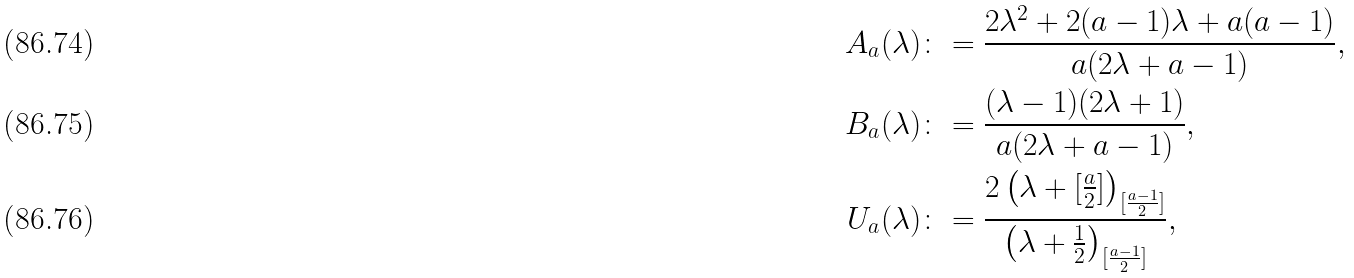Convert formula to latex. <formula><loc_0><loc_0><loc_500><loc_500>A _ { a } ( \lambda ) & \colon = \frac { 2 \lambda ^ { 2 } + 2 ( a - 1 ) \lambda + a ( a - 1 ) } { a ( 2 \lambda + a - 1 ) } , \\ B _ { a } ( \lambda ) & \colon = \frac { ( \lambda - 1 ) ( 2 \lambda + 1 ) } { a ( 2 \lambda + a - 1 ) } , \\ U _ { a } ( \lambda ) & \colon = \frac { 2 \left ( \lambda + [ \frac { a } { 2 } ] \right ) _ { [ \frac { a - 1 } { 2 } ] } } { \left ( \lambda + \frac { 1 } { 2 } \right ) _ { [ \frac { a - 1 } { 2 } ] } } ,</formula> 